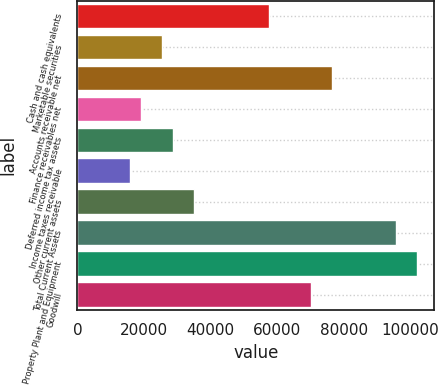Convert chart. <chart><loc_0><loc_0><loc_500><loc_500><bar_chart><fcel>Cash and cash equivalents<fcel>Marketable securities<fcel>Accounts receivable net<fcel>Finance receivables net<fcel>Deferred income tax assets<fcel>Income taxes receivable<fcel>Other current assets<fcel>Total Current Assets<fcel>Property Plant and Equipment<fcel>Goodwill<nl><fcel>57387<fcel>25507<fcel>76515<fcel>19131<fcel>28695<fcel>15943<fcel>35071<fcel>95643<fcel>102019<fcel>70139<nl></chart> 